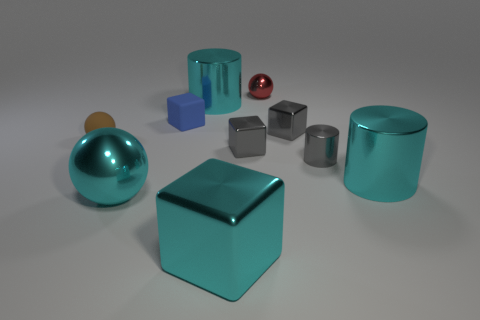Subtract all red blocks. Subtract all blue cylinders. How many blocks are left? 4 Subtract all cylinders. How many objects are left? 7 Subtract all cyan blocks. Subtract all cylinders. How many objects are left? 6 Add 1 red balls. How many red balls are left? 2 Add 10 green objects. How many green objects exist? 10 Subtract 0 blue cylinders. How many objects are left? 10 